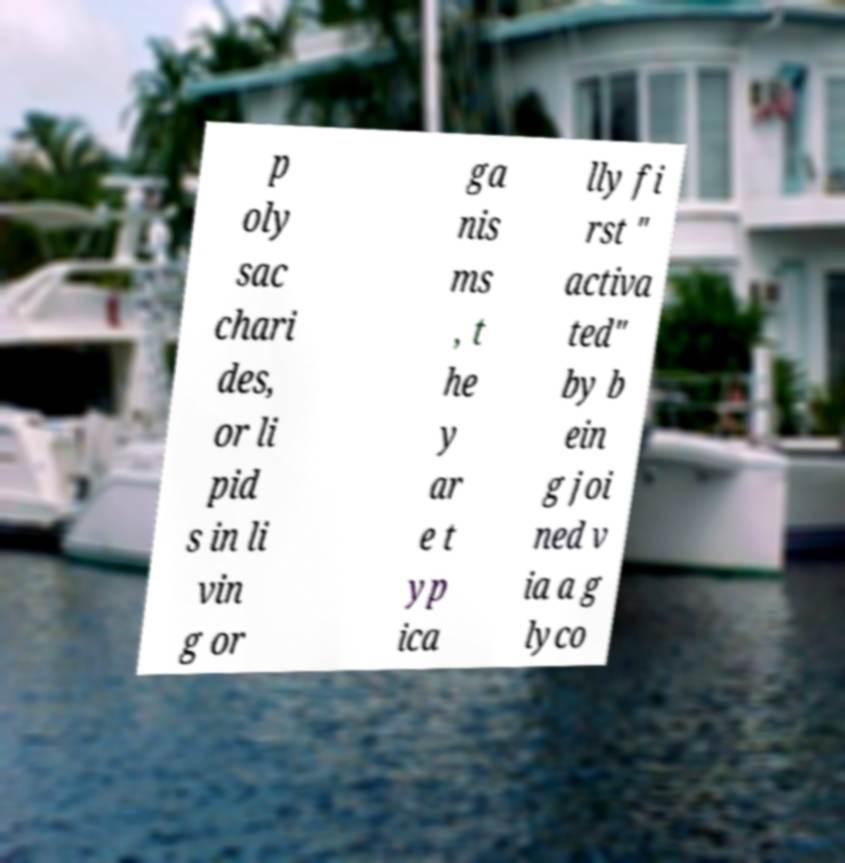Can you accurately transcribe the text from the provided image for me? p oly sac chari des, or li pid s in li vin g or ga nis ms , t he y ar e t yp ica lly fi rst " activa ted" by b ein g joi ned v ia a g lyco 